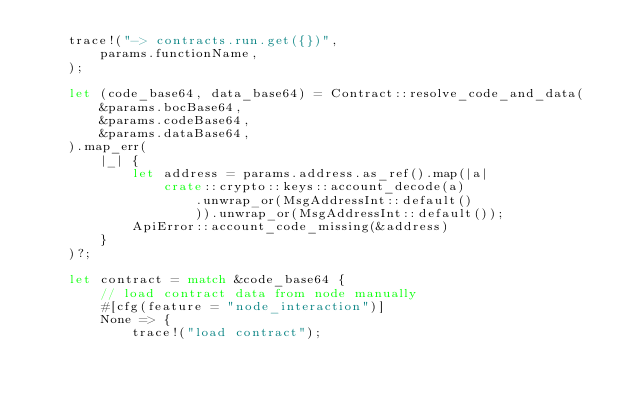<code> <loc_0><loc_0><loc_500><loc_500><_Rust_>    trace!("-> contracts.run.get({})",
        params.functionName,
    );

    let (code_base64, data_base64) = Contract::resolve_code_and_data(
        &params.bocBase64,
        &params.codeBase64,
        &params.dataBase64,
    ).map_err(
        |_| {
            let address = params.address.as_ref().map(|a|
                crate::crypto::keys::account_decode(a)
                    .unwrap_or(MsgAddressInt::default()
                    )).unwrap_or(MsgAddressInt::default());
            ApiError::account_code_missing(&address)
        }
    )?;

    let contract = match &code_base64 {
        // load contract data from node manually
        #[cfg(feature = "node_interaction")]
        None => {
            trace!("load contract");</code> 